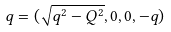Convert formula to latex. <formula><loc_0><loc_0><loc_500><loc_500>q = ( { \sqrt { q ^ { 2 } - Q ^ { 2 } } } , 0 , 0 , - q )</formula> 